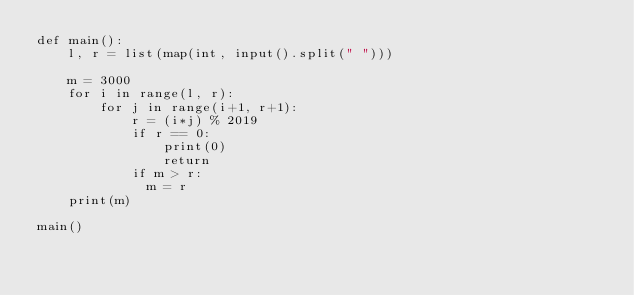<code> <loc_0><loc_0><loc_500><loc_500><_Python_>def main():
    l, r = list(map(int, input().split(" ")))
 
    m = 3000
    for i in range(l, r):
        for j in range(i+1, r+1):
            r = (i*j) % 2019
            if r == 0:
                print(0)
                return
            if m > r:
              m = r
    print(m)

main()</code> 